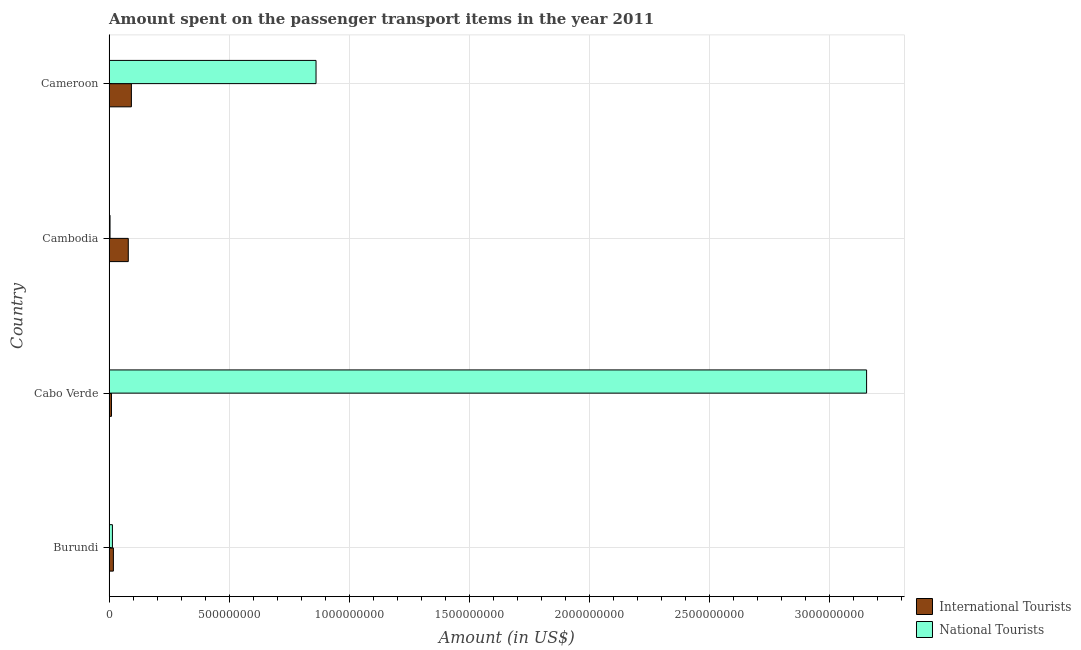Are the number of bars on each tick of the Y-axis equal?
Ensure brevity in your answer.  Yes. How many bars are there on the 4th tick from the top?
Make the answer very short. 2. What is the label of the 3rd group of bars from the top?
Your answer should be very brief. Cabo Verde. What is the amount spent on transport items of international tourists in Burundi?
Provide a short and direct response. 1.80e+07. Across all countries, what is the maximum amount spent on transport items of national tourists?
Make the answer very short. 3.16e+09. Across all countries, what is the minimum amount spent on transport items of national tourists?
Provide a short and direct response. 4.00e+06. In which country was the amount spent on transport items of national tourists maximum?
Offer a very short reply. Cabo Verde. In which country was the amount spent on transport items of national tourists minimum?
Your answer should be compact. Cambodia. What is the total amount spent on transport items of national tourists in the graph?
Provide a succinct answer. 4.04e+09. What is the difference between the amount spent on transport items of international tourists in Burundi and that in Cameroon?
Give a very brief answer. -7.50e+07. What is the difference between the amount spent on transport items of national tourists in Cameroon and the amount spent on transport items of international tourists in Cabo Verde?
Make the answer very short. 8.52e+08. What is the average amount spent on transport items of international tourists per country?
Your answer should be compact. 5.02e+07. What is the difference between the amount spent on transport items of national tourists and amount spent on transport items of international tourists in Cambodia?
Make the answer very short. -7.60e+07. What is the ratio of the amount spent on transport items of international tourists in Cabo Verde to that in Cambodia?
Provide a succinct answer. 0.12. What is the difference between the highest and the second highest amount spent on transport items of national tourists?
Provide a short and direct response. 2.29e+09. What is the difference between the highest and the lowest amount spent on transport items of international tourists?
Provide a short and direct response. 8.30e+07. In how many countries, is the amount spent on transport items of international tourists greater than the average amount spent on transport items of international tourists taken over all countries?
Make the answer very short. 2. Is the sum of the amount spent on transport items of international tourists in Cambodia and Cameroon greater than the maximum amount spent on transport items of national tourists across all countries?
Your answer should be very brief. No. What does the 2nd bar from the top in Cameroon represents?
Give a very brief answer. International Tourists. What does the 2nd bar from the bottom in Cambodia represents?
Keep it short and to the point. National Tourists. Are the values on the major ticks of X-axis written in scientific E-notation?
Provide a succinct answer. No. Does the graph contain any zero values?
Provide a succinct answer. No. Where does the legend appear in the graph?
Your answer should be very brief. Bottom right. How many legend labels are there?
Provide a short and direct response. 2. How are the legend labels stacked?
Offer a terse response. Vertical. What is the title of the graph?
Your answer should be compact. Amount spent on the passenger transport items in the year 2011. What is the label or title of the X-axis?
Offer a terse response. Amount (in US$). What is the Amount (in US$) in International Tourists in Burundi?
Give a very brief answer. 1.80e+07. What is the Amount (in US$) of National Tourists in Burundi?
Your answer should be very brief. 1.40e+07. What is the Amount (in US$) of National Tourists in Cabo Verde?
Offer a very short reply. 3.16e+09. What is the Amount (in US$) of International Tourists in Cambodia?
Your response must be concise. 8.00e+07. What is the Amount (in US$) in International Tourists in Cameroon?
Provide a succinct answer. 9.30e+07. What is the Amount (in US$) of National Tourists in Cameroon?
Provide a short and direct response. 8.62e+08. Across all countries, what is the maximum Amount (in US$) in International Tourists?
Your answer should be very brief. 9.30e+07. Across all countries, what is the maximum Amount (in US$) of National Tourists?
Give a very brief answer. 3.16e+09. Across all countries, what is the minimum Amount (in US$) of National Tourists?
Provide a short and direct response. 4.00e+06. What is the total Amount (in US$) of International Tourists in the graph?
Ensure brevity in your answer.  2.01e+08. What is the total Amount (in US$) of National Tourists in the graph?
Provide a short and direct response. 4.04e+09. What is the difference between the Amount (in US$) in National Tourists in Burundi and that in Cabo Verde?
Offer a very short reply. -3.14e+09. What is the difference between the Amount (in US$) of International Tourists in Burundi and that in Cambodia?
Ensure brevity in your answer.  -6.20e+07. What is the difference between the Amount (in US$) of International Tourists in Burundi and that in Cameroon?
Keep it short and to the point. -7.50e+07. What is the difference between the Amount (in US$) in National Tourists in Burundi and that in Cameroon?
Your answer should be very brief. -8.48e+08. What is the difference between the Amount (in US$) in International Tourists in Cabo Verde and that in Cambodia?
Your answer should be very brief. -7.00e+07. What is the difference between the Amount (in US$) of National Tourists in Cabo Verde and that in Cambodia?
Keep it short and to the point. 3.15e+09. What is the difference between the Amount (in US$) in International Tourists in Cabo Verde and that in Cameroon?
Offer a terse response. -8.30e+07. What is the difference between the Amount (in US$) of National Tourists in Cabo Verde and that in Cameroon?
Ensure brevity in your answer.  2.29e+09. What is the difference between the Amount (in US$) in International Tourists in Cambodia and that in Cameroon?
Provide a short and direct response. -1.30e+07. What is the difference between the Amount (in US$) in National Tourists in Cambodia and that in Cameroon?
Ensure brevity in your answer.  -8.58e+08. What is the difference between the Amount (in US$) of International Tourists in Burundi and the Amount (in US$) of National Tourists in Cabo Verde?
Give a very brief answer. -3.14e+09. What is the difference between the Amount (in US$) in International Tourists in Burundi and the Amount (in US$) in National Tourists in Cambodia?
Offer a terse response. 1.40e+07. What is the difference between the Amount (in US$) in International Tourists in Burundi and the Amount (in US$) in National Tourists in Cameroon?
Your answer should be compact. -8.44e+08. What is the difference between the Amount (in US$) in International Tourists in Cabo Verde and the Amount (in US$) in National Tourists in Cameroon?
Keep it short and to the point. -8.52e+08. What is the difference between the Amount (in US$) of International Tourists in Cambodia and the Amount (in US$) of National Tourists in Cameroon?
Your answer should be very brief. -7.82e+08. What is the average Amount (in US$) in International Tourists per country?
Give a very brief answer. 5.02e+07. What is the average Amount (in US$) of National Tourists per country?
Provide a short and direct response. 1.01e+09. What is the difference between the Amount (in US$) in International Tourists and Amount (in US$) in National Tourists in Burundi?
Your answer should be very brief. 4.00e+06. What is the difference between the Amount (in US$) in International Tourists and Amount (in US$) in National Tourists in Cabo Verde?
Ensure brevity in your answer.  -3.14e+09. What is the difference between the Amount (in US$) in International Tourists and Amount (in US$) in National Tourists in Cambodia?
Your answer should be very brief. 7.60e+07. What is the difference between the Amount (in US$) of International Tourists and Amount (in US$) of National Tourists in Cameroon?
Your answer should be very brief. -7.69e+08. What is the ratio of the Amount (in US$) of National Tourists in Burundi to that in Cabo Verde?
Your answer should be very brief. 0. What is the ratio of the Amount (in US$) of International Tourists in Burundi to that in Cambodia?
Make the answer very short. 0.23. What is the ratio of the Amount (in US$) in National Tourists in Burundi to that in Cambodia?
Provide a short and direct response. 3.5. What is the ratio of the Amount (in US$) in International Tourists in Burundi to that in Cameroon?
Keep it short and to the point. 0.19. What is the ratio of the Amount (in US$) of National Tourists in Burundi to that in Cameroon?
Keep it short and to the point. 0.02. What is the ratio of the Amount (in US$) of International Tourists in Cabo Verde to that in Cambodia?
Offer a terse response. 0.12. What is the ratio of the Amount (in US$) in National Tourists in Cabo Verde to that in Cambodia?
Provide a short and direct response. 788.75. What is the ratio of the Amount (in US$) of International Tourists in Cabo Verde to that in Cameroon?
Provide a succinct answer. 0.11. What is the ratio of the Amount (in US$) of National Tourists in Cabo Verde to that in Cameroon?
Keep it short and to the point. 3.66. What is the ratio of the Amount (in US$) of International Tourists in Cambodia to that in Cameroon?
Ensure brevity in your answer.  0.86. What is the ratio of the Amount (in US$) of National Tourists in Cambodia to that in Cameroon?
Make the answer very short. 0. What is the difference between the highest and the second highest Amount (in US$) in International Tourists?
Make the answer very short. 1.30e+07. What is the difference between the highest and the second highest Amount (in US$) of National Tourists?
Give a very brief answer. 2.29e+09. What is the difference between the highest and the lowest Amount (in US$) of International Tourists?
Provide a short and direct response. 8.30e+07. What is the difference between the highest and the lowest Amount (in US$) in National Tourists?
Your response must be concise. 3.15e+09. 